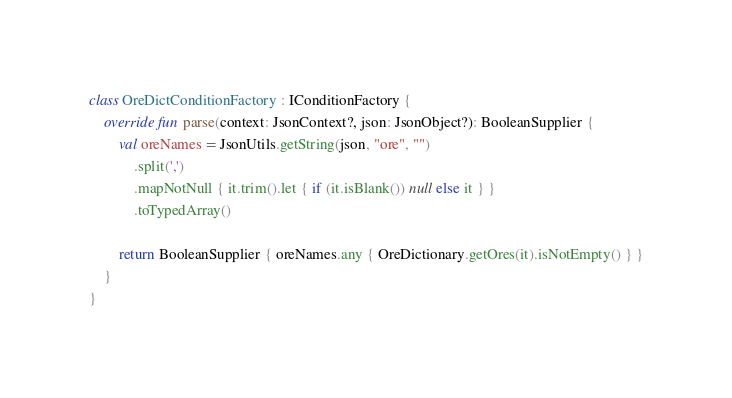<code> <loc_0><loc_0><loc_500><loc_500><_Kotlin_>
class OreDictConditionFactory : IConditionFactory {
    override fun parse(context: JsonContext?, json: JsonObject?): BooleanSupplier {
        val oreNames = JsonUtils.getString(json, "ore", "")
            .split(',')
            .mapNotNull { it.trim().let { if (it.isBlank()) null else it } }
            .toTypedArray()

        return BooleanSupplier { oreNames.any { OreDictionary.getOres(it).isNotEmpty() } }
    }
}
</code> 